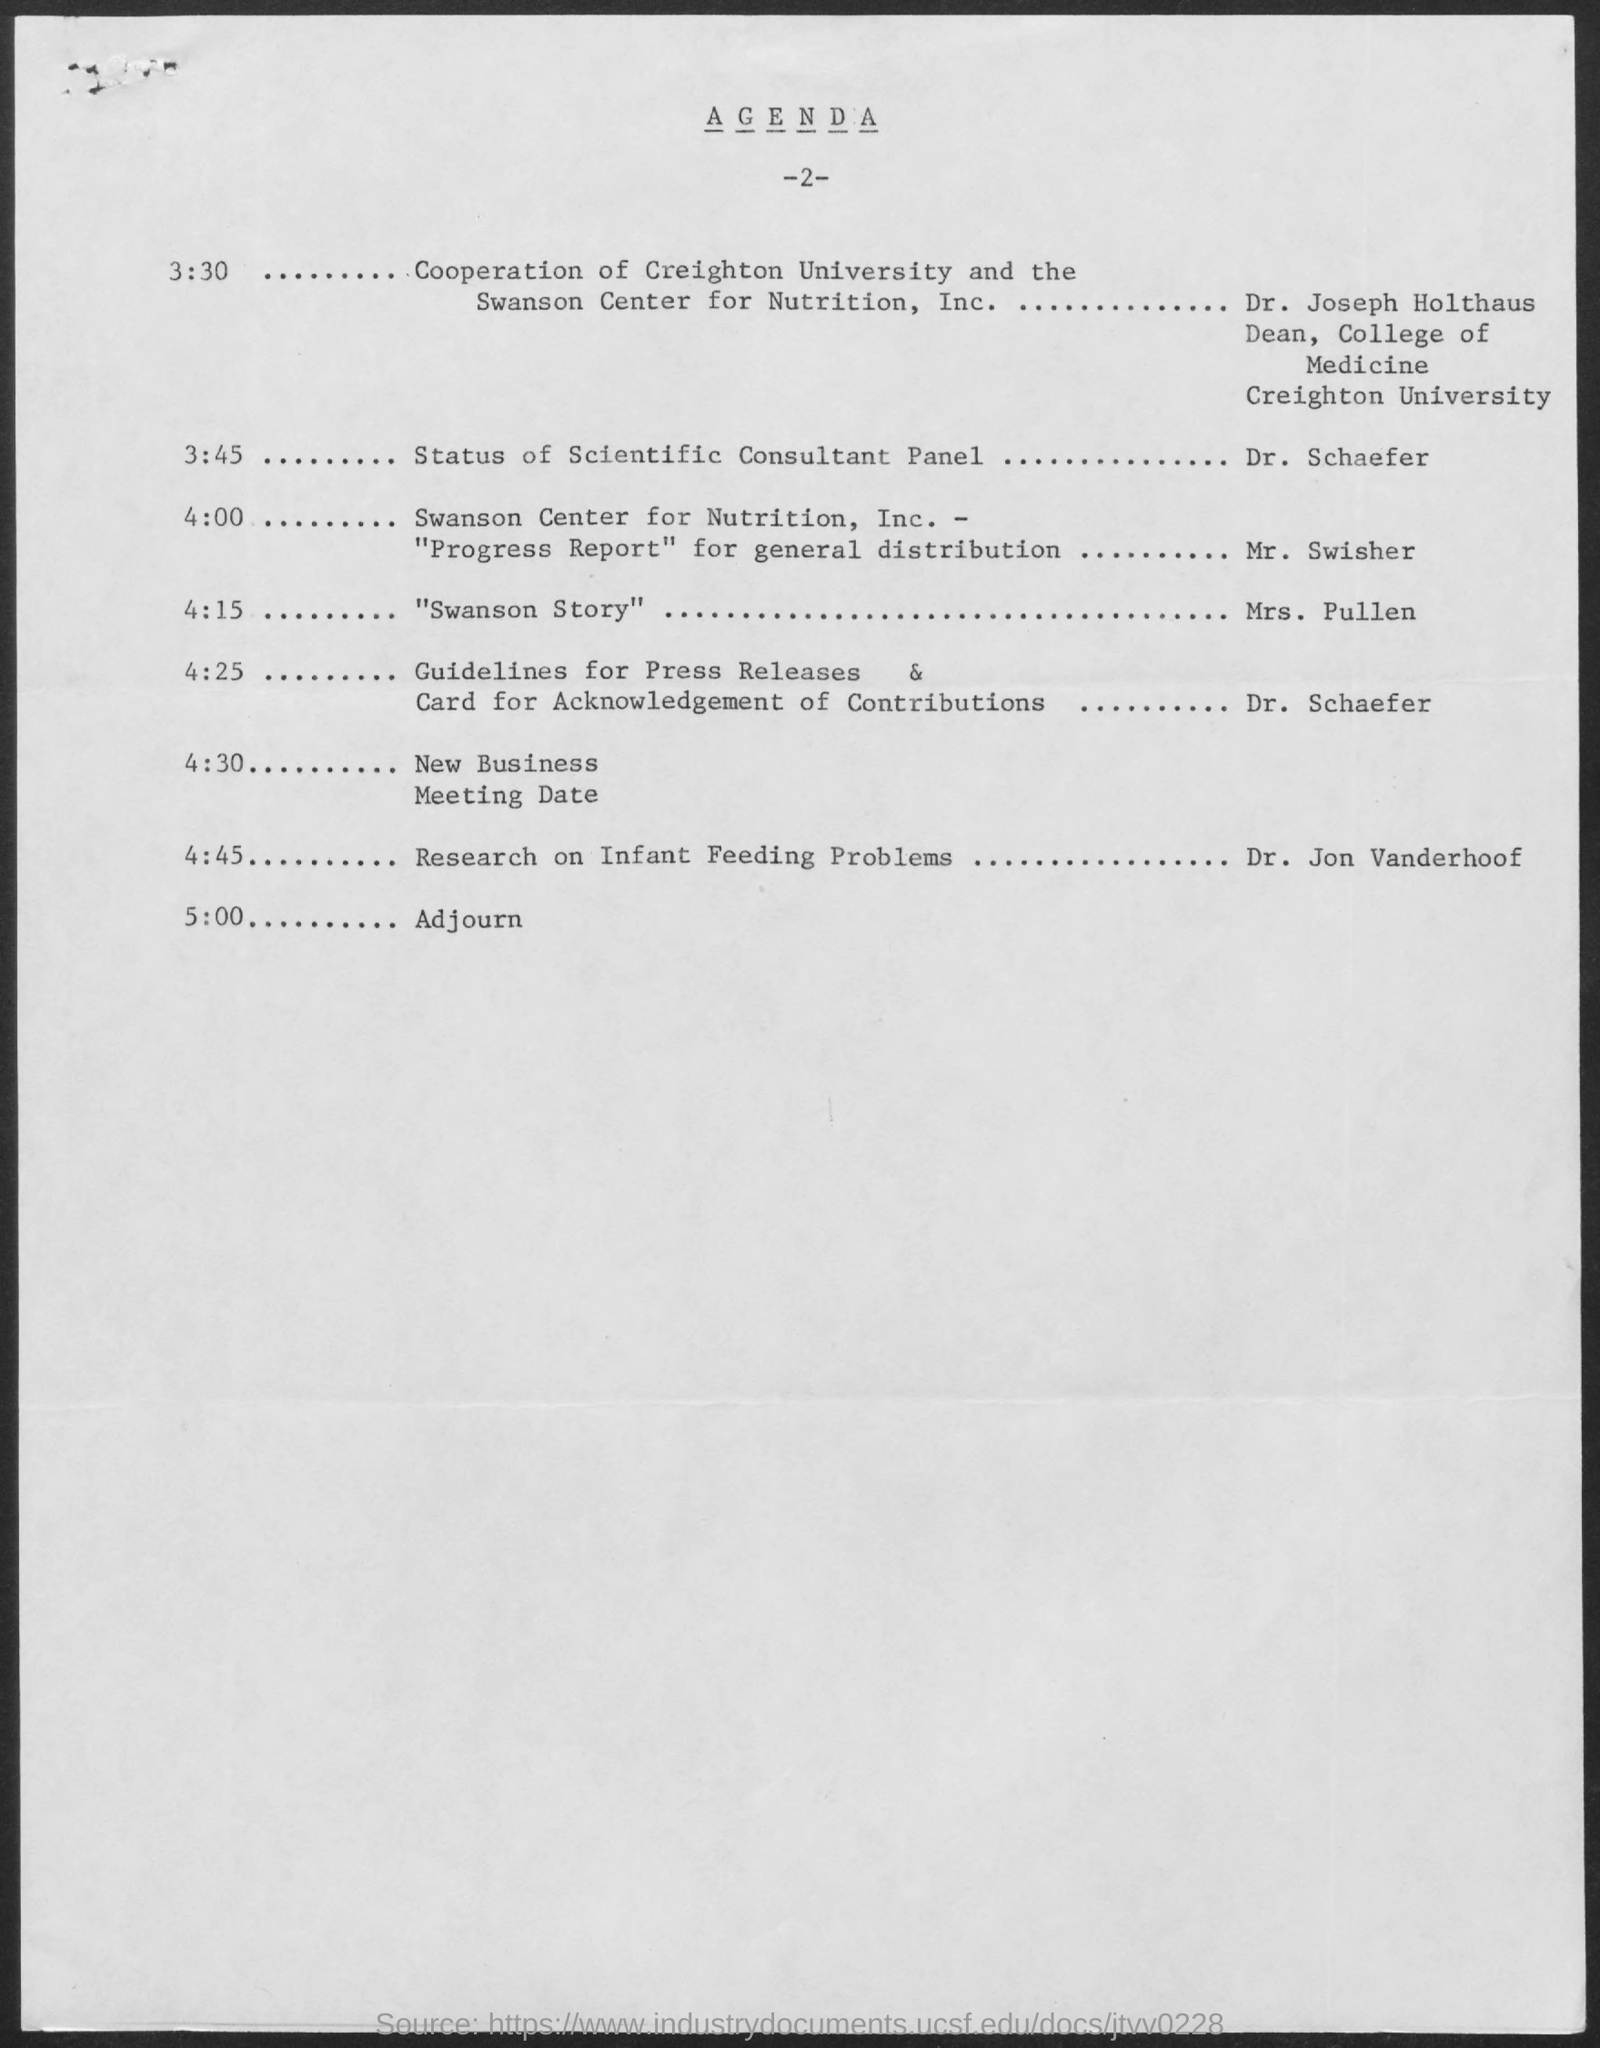List a handful of essential elements in this visual. The title of the document is 'Agenda.' 